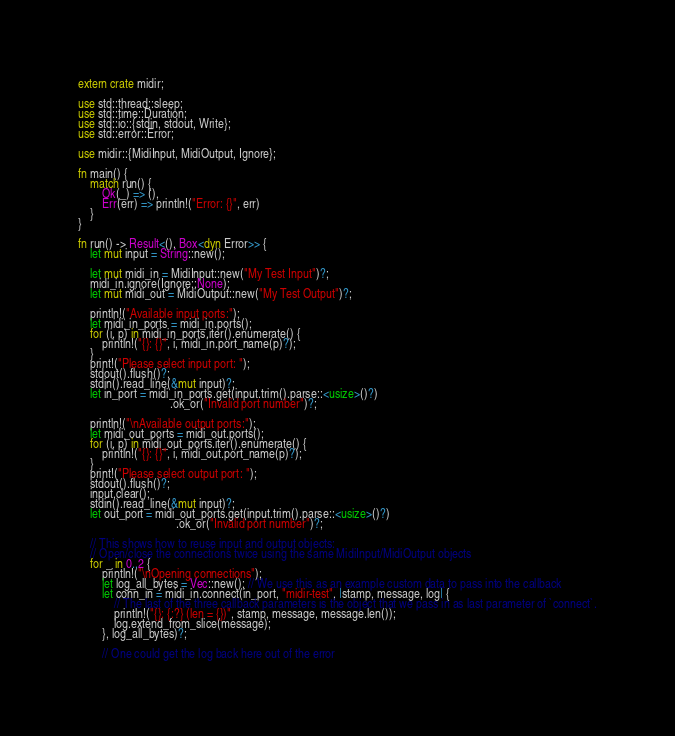Convert code to text. <code><loc_0><loc_0><loc_500><loc_500><_Rust_>extern crate midir;

use std::thread::sleep;
use std::time::Duration;
use std::io::{stdin, stdout, Write};
use std::error::Error;

use midir::{MidiInput, MidiOutput, Ignore};

fn main() {
    match run() {
        Ok(_) => (),
        Err(err) => println!("Error: {}", err)
    }
}

fn run() -> Result<(), Box<dyn Error>> {
    let mut input = String::new();
    
    let mut midi_in = MidiInput::new("My Test Input")?;
    midi_in.ignore(Ignore::None);
    let mut midi_out = MidiOutput::new("My Test Output")?;
    
    println!("Available input ports:");
    let midi_in_ports = midi_in.ports();
    for (i, p) in midi_in_ports.iter().enumerate() {
        println!("{}: {}", i, midi_in.port_name(p)?);
    }
    print!("Please select input port: ");
    stdout().flush()?;
    stdin().read_line(&mut input)?;
    let in_port = midi_in_ports.get(input.trim().parse::<usize>()?)
                               .ok_or("Invalid port number")?;
    
    println!("\nAvailable output ports:");
    let midi_out_ports = midi_out.ports();
    for (i, p) in midi_out_ports.iter().enumerate() {
        println!("{}: {}", i, midi_out.port_name(p)?);
    }
    print!("Please select output port: ");
    stdout().flush()?;
    input.clear();
    stdin().read_line(&mut input)?;
    let out_port = midi_out_ports.get(input.trim().parse::<usize>()?)
                                 .ok_or("Invalid port number")?;
    
    // This shows how to reuse input and output objects:
    // Open/close the connections twice using the same MidiInput/MidiOutput objects
    for _ in 0..2 {
        println!("\nOpening connections");
        let log_all_bytes = Vec::new(); // We use this as an example custom data to pass into the callback
        let conn_in = midi_in.connect(in_port, "midir-test", |stamp, message, log| {
            // The last of the three callback parameters is the object that we pass in as last parameter of `connect`.
            println!("{}: {:?} (len = {})", stamp, message, message.len());
            log.extend_from_slice(message);
        }, log_all_bytes)?;
        
        // One could get the log back here out of the error</code> 